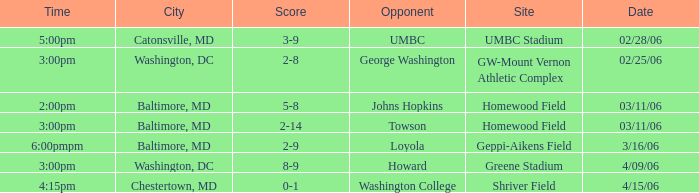Which site has a Score of 0-1? Shriver Field. 